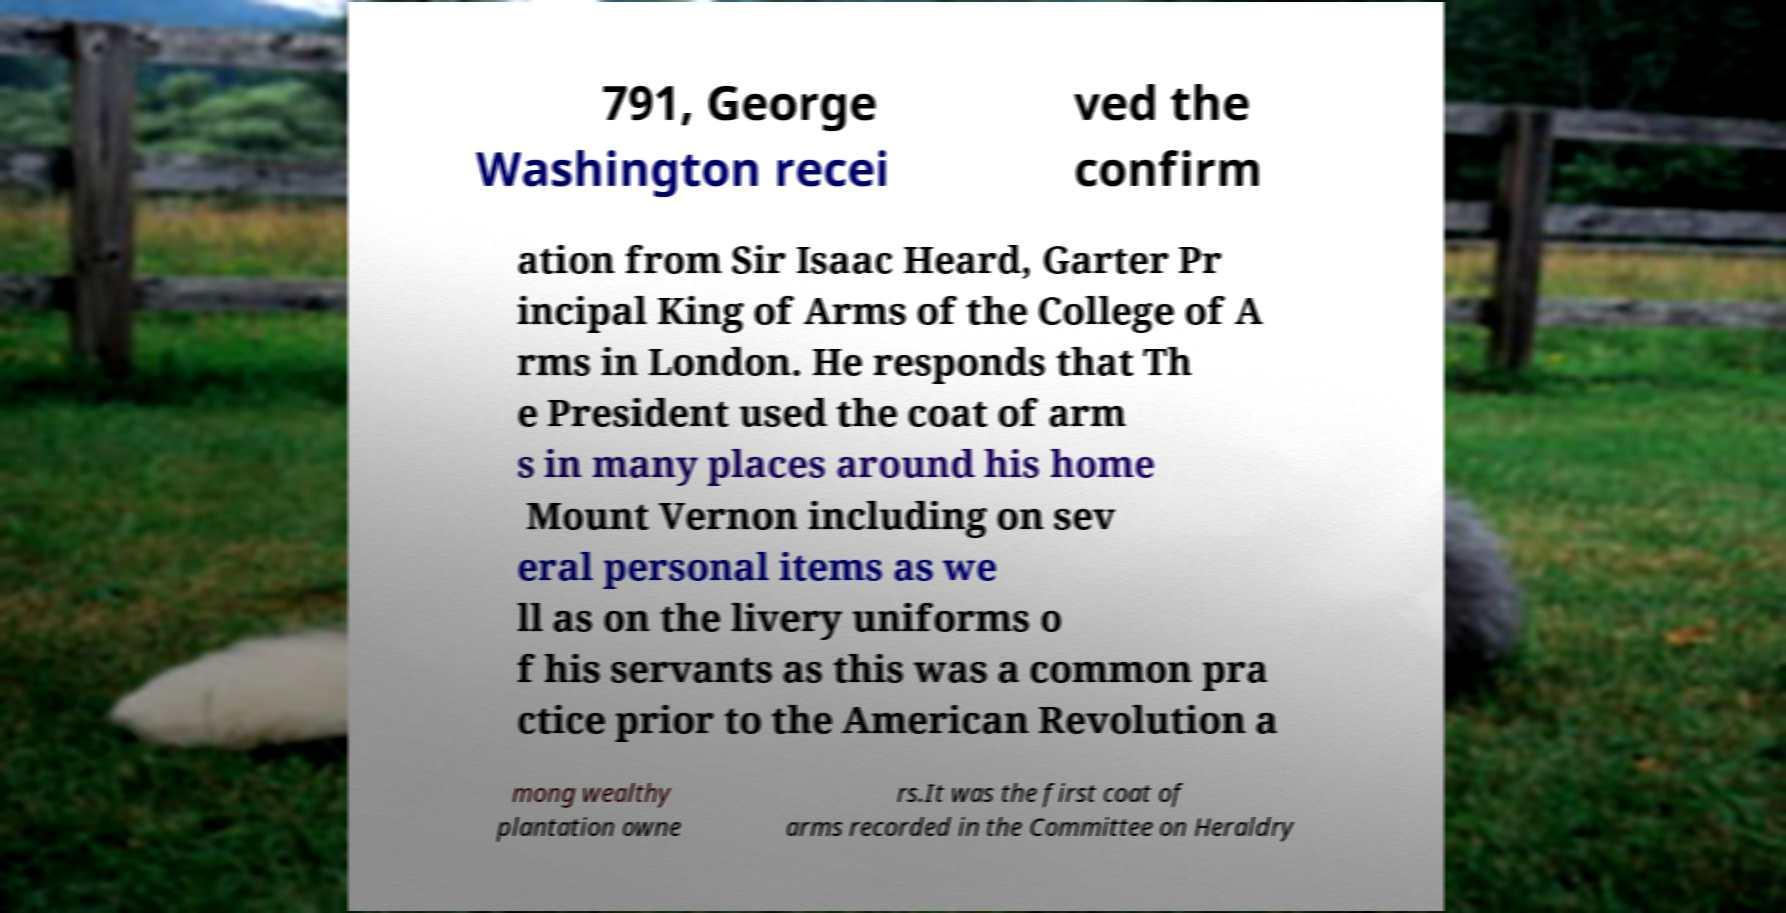Could you extract and type out the text from this image? 791, George Washington recei ved the confirm ation from Sir Isaac Heard, Garter Pr incipal King of Arms of the College of A rms in London. He responds that Th e President used the coat of arm s in many places around his home Mount Vernon including on sev eral personal items as we ll as on the livery uniforms o f his servants as this was a common pra ctice prior to the American Revolution a mong wealthy plantation owne rs.It was the first coat of arms recorded in the Committee on Heraldry 